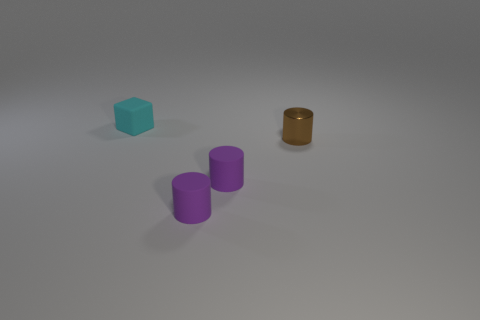Subtract all small matte cylinders. How many cylinders are left? 1 Subtract all green blocks. How many purple cylinders are left? 2 Subtract all purple cylinders. How many cylinders are left? 1 Subtract all cubes. How many objects are left? 3 Add 4 small brown rubber balls. How many objects exist? 8 Subtract 3 cylinders. How many cylinders are left? 0 Subtract all purple cylinders. Subtract all yellow spheres. How many cylinders are left? 1 Subtract all tiny purple matte cylinders. Subtract all brown things. How many objects are left? 1 Add 1 brown metal cylinders. How many brown metal cylinders are left? 2 Add 2 brown things. How many brown things exist? 3 